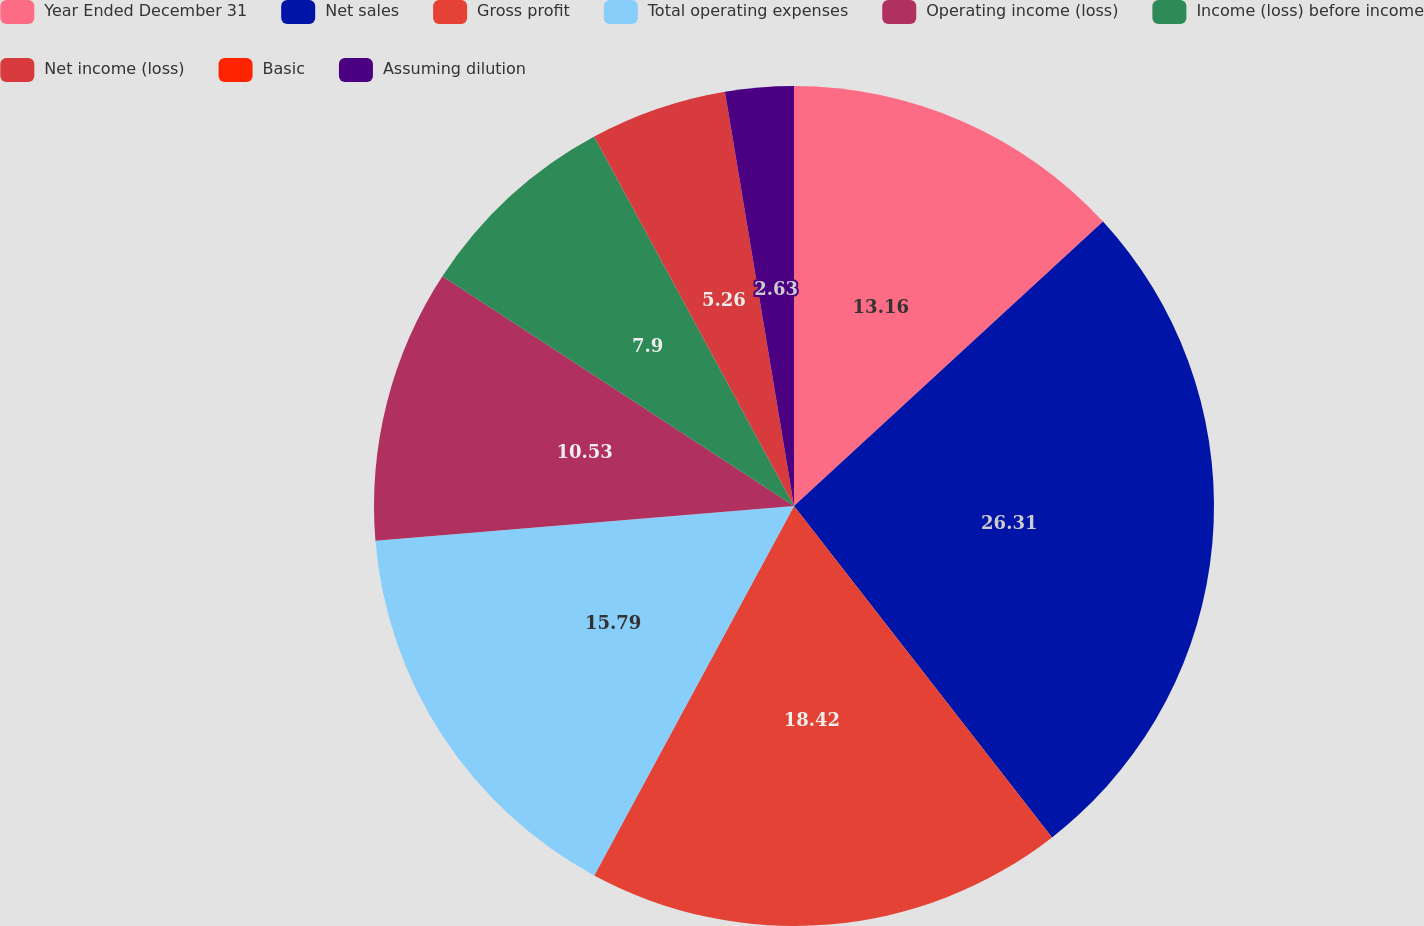Convert chart. <chart><loc_0><loc_0><loc_500><loc_500><pie_chart><fcel>Year Ended December 31<fcel>Net sales<fcel>Gross profit<fcel>Total operating expenses<fcel>Operating income (loss)<fcel>Income (loss) before income<fcel>Net income (loss)<fcel>Basic<fcel>Assuming dilution<nl><fcel>13.16%<fcel>26.31%<fcel>18.42%<fcel>15.79%<fcel>10.53%<fcel>7.9%<fcel>5.26%<fcel>0.0%<fcel>2.63%<nl></chart> 